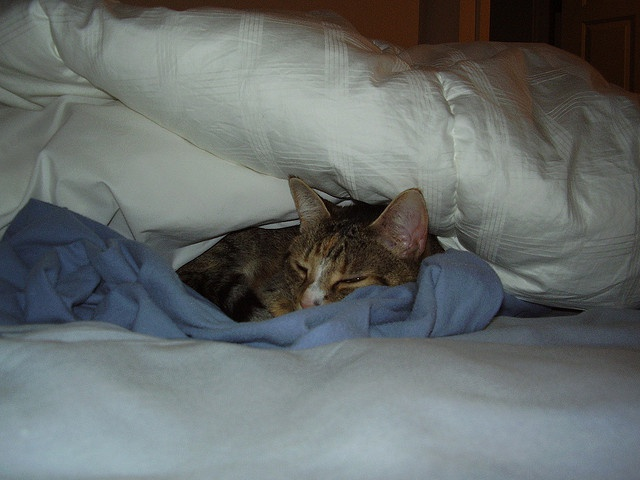Describe the objects in this image and their specific colors. I can see bed in darkgray, gray, and black tones and cat in black and gray tones in this image. 